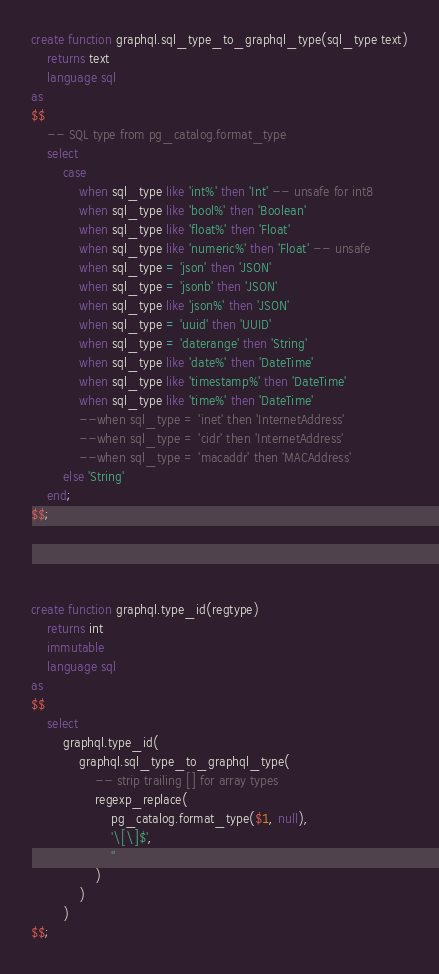<code> <loc_0><loc_0><loc_500><loc_500><_SQL_>create function graphql.sql_type_to_graphql_type(sql_type text)
    returns text
    language sql
as
$$
    -- SQL type from pg_catalog.format_type
    select
        case
            when sql_type like 'int%' then 'Int' -- unsafe for int8
            when sql_type like 'bool%' then 'Boolean'
            when sql_type like 'float%' then 'Float'
            when sql_type like 'numeric%' then 'Float' -- unsafe
            when sql_type = 'json' then 'JSON'
            when sql_type = 'jsonb' then 'JSON'
            when sql_type like 'json%' then 'JSON'
            when sql_type = 'uuid' then 'UUID'
            when sql_type = 'daterange' then 'String'
            when sql_type like 'date%' then 'DateTime'
            when sql_type like 'timestamp%' then 'DateTime'
            when sql_type like 'time%' then 'DateTime'
            --when sql_type = 'inet' then 'InternetAddress'
            --when sql_type = 'cidr' then 'InternetAddress'
            --when sql_type = 'macaddr' then 'MACAddress'
        else 'String'
    end;
$$;




create function graphql.type_id(regtype)
    returns int
    immutable
    language sql
as
$$
    select
        graphql.type_id(
            graphql.sql_type_to_graphql_type(
                -- strip trailing [] for array types
                regexp_replace(
                    pg_catalog.format_type($1, null),
                    '\[\]$',
                    ''
                )
            )
        )
$$;
</code> 